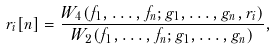<formula> <loc_0><loc_0><loc_500><loc_500>r _ { i } [ n ] = \frac { W _ { 4 } ( f _ { 1 } , \dots , f _ { n } ; g _ { 1 } , \dots , g _ { n } , r _ { i } ) } { W _ { 2 } ( f _ { 1 } , \dots , f _ { n } ; g _ { 1 } , \dots , g _ { n } ) } ,</formula> 